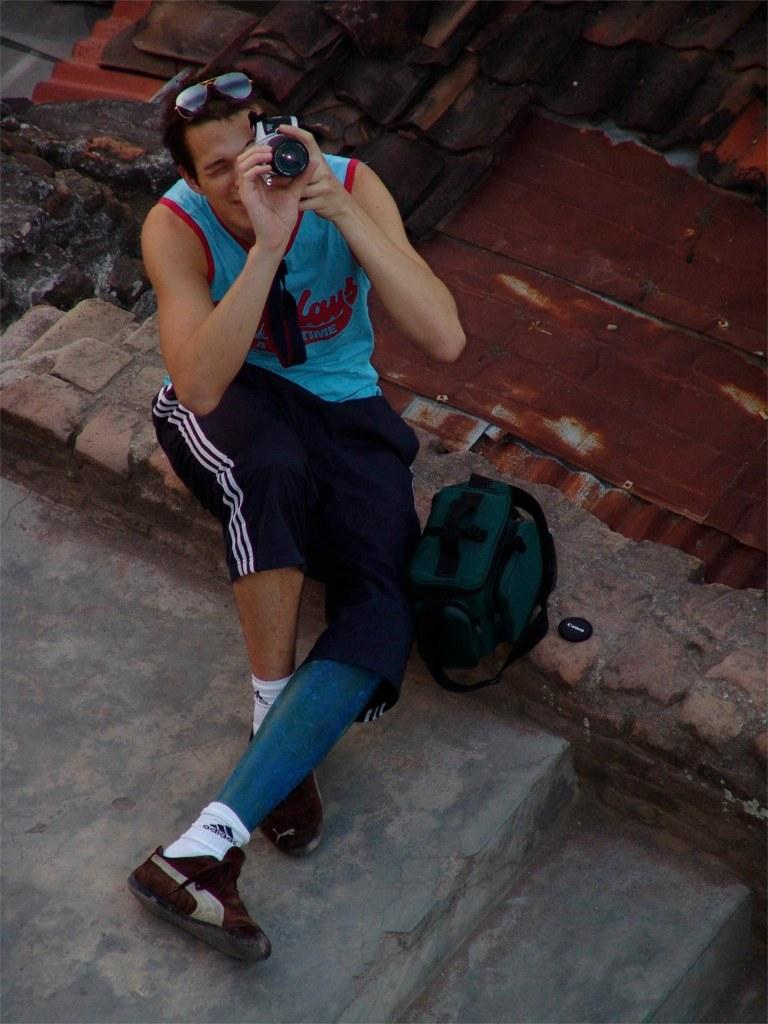What is the main subject of the image? There is a person in the image. Can you describe the person's clothing? The person is wearing a dress with blue, red, and black colors. What is the person doing in the image? The person is sitting. What object is the person holding in his hand? The person is holding a camera in his hand. What is located beside the person? There is a bag beside the person. What can be seen in the background of the image? There are roofs visible in the background of the image. How many apples are hanging from the rod in the image? There is no rod or apples present in the image. What type of moon can be seen in the image? There is no moon visible in the image. 